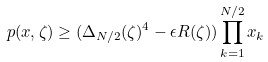<formula> <loc_0><loc_0><loc_500><loc_500>p ( x , \zeta ) \geq ( \Delta _ { N / 2 } ( \zeta ) ^ { 4 } - \epsilon R ( \zeta ) ) \prod _ { k = 1 } ^ { N / 2 } x _ { k }</formula> 